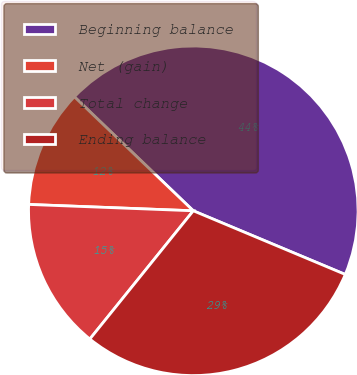Convert chart. <chart><loc_0><loc_0><loc_500><loc_500><pie_chart><fcel>Beginning balance<fcel>Net (gain)<fcel>Total change<fcel>Ending balance<nl><fcel>44.15%<fcel>11.55%<fcel>14.81%<fcel>29.49%<nl></chart> 